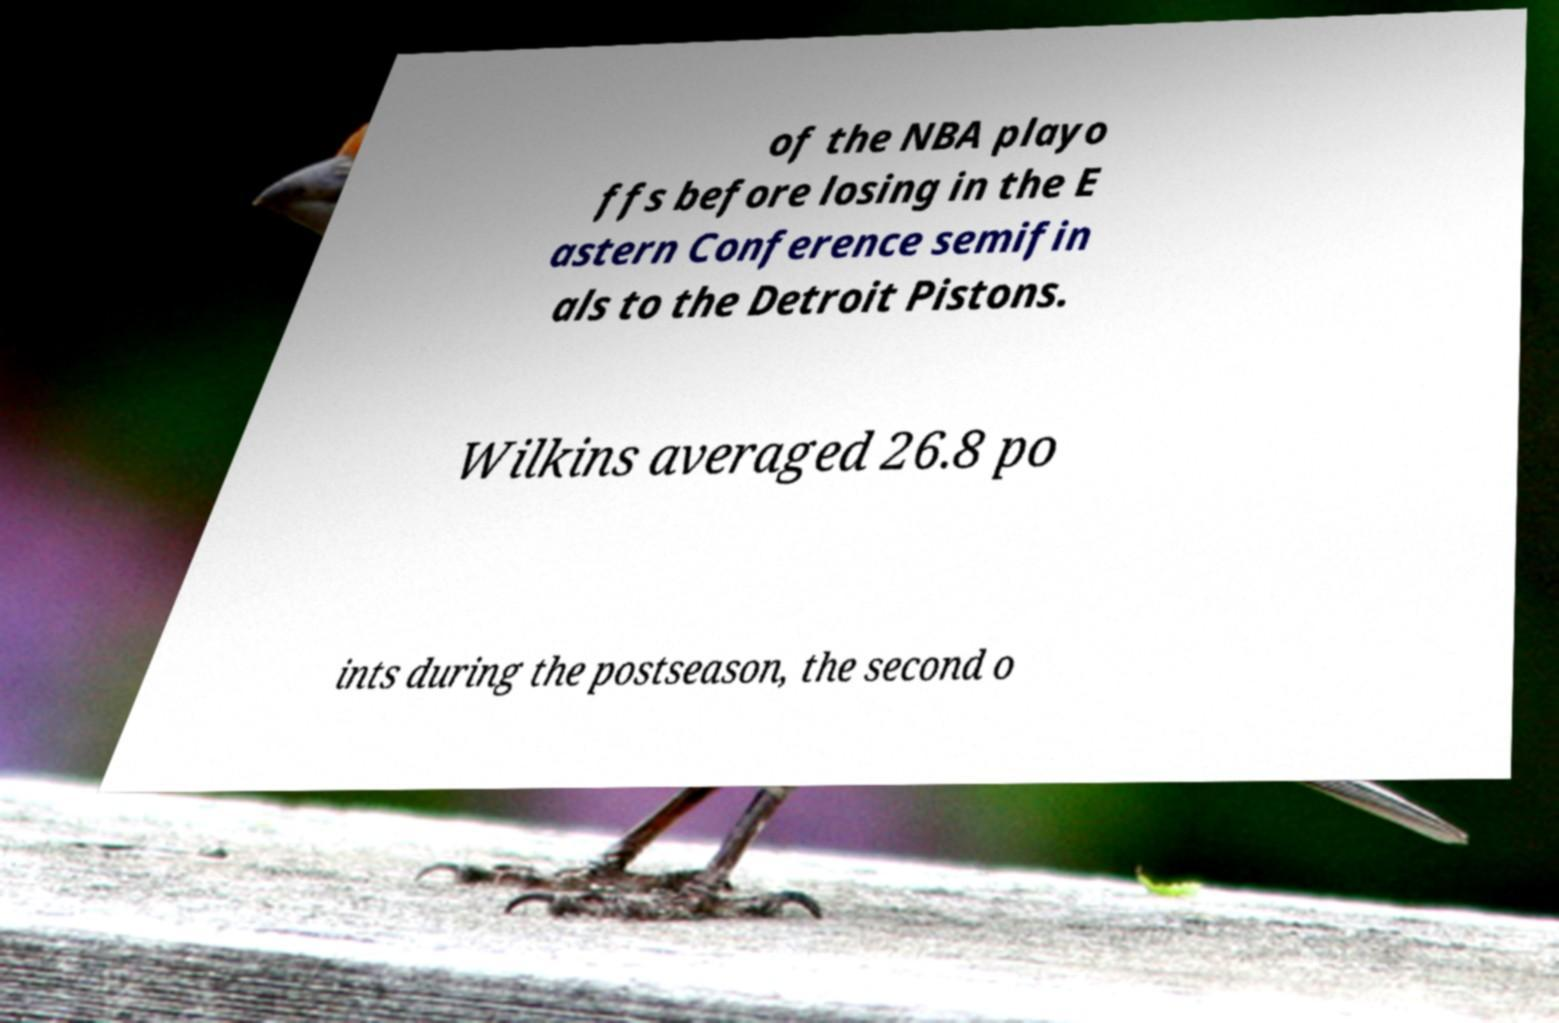Please read and relay the text visible in this image. What does it say? of the NBA playo ffs before losing in the E astern Conference semifin als to the Detroit Pistons. Wilkins averaged 26.8 po ints during the postseason, the second o 